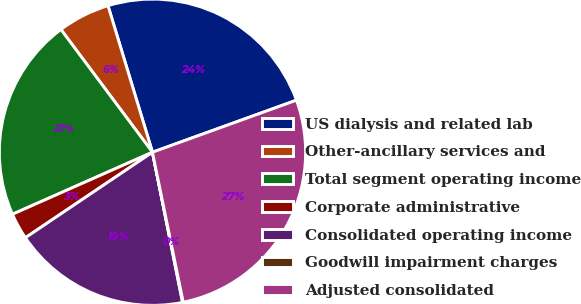Convert chart to OTSL. <chart><loc_0><loc_0><loc_500><loc_500><pie_chart><fcel>US dialysis and related lab<fcel>Other-ancillary services and<fcel>Total segment operating income<fcel>Corporate administrative<fcel>Consolidated operating income<fcel>Goodwill impairment charges<fcel>Adjusted consolidated<nl><fcel>24.17%<fcel>5.51%<fcel>21.44%<fcel>2.79%<fcel>18.72%<fcel>0.07%<fcel>27.3%<nl></chart> 